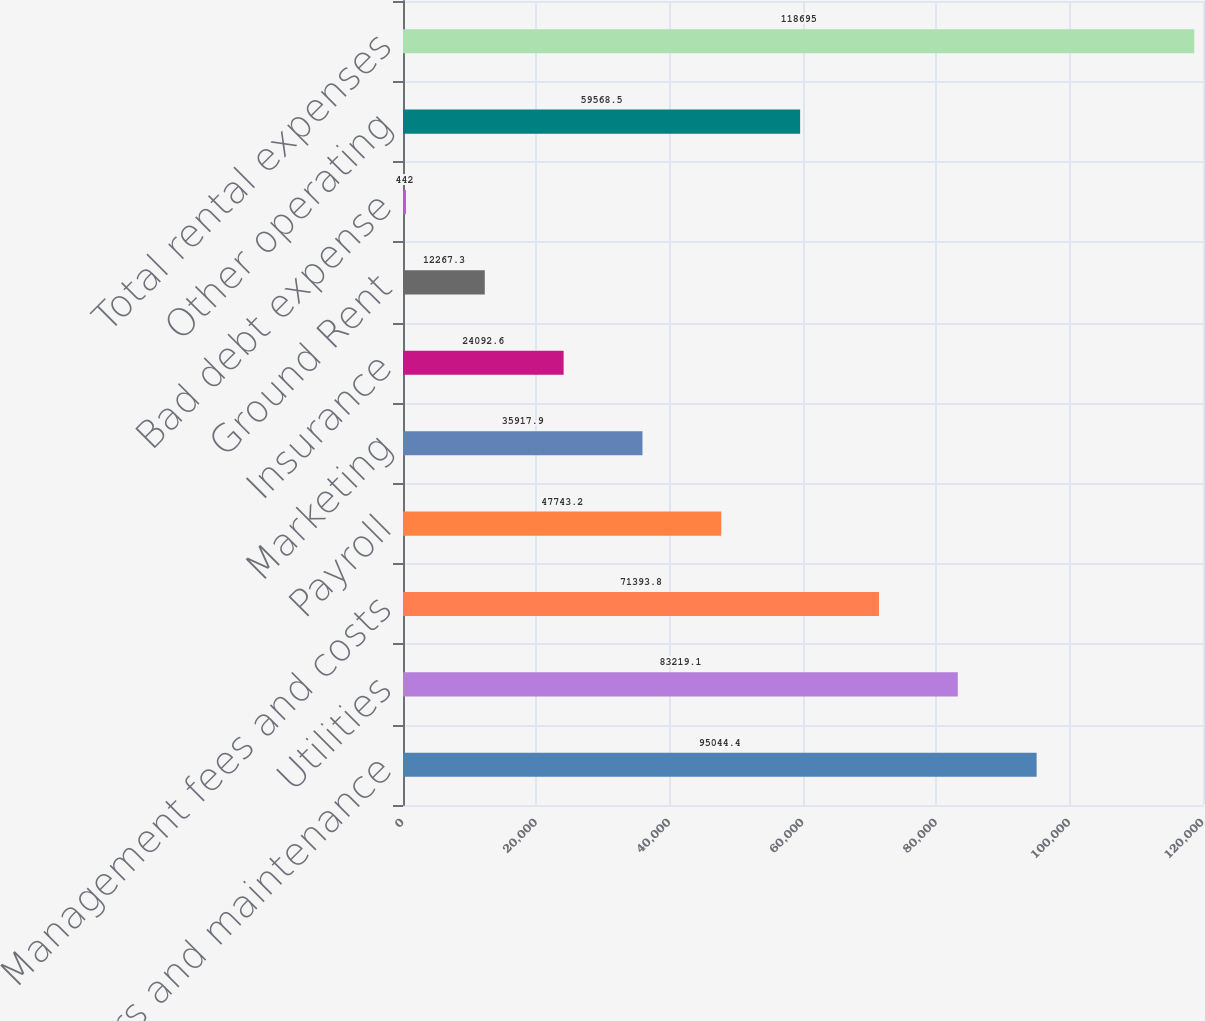Convert chart. <chart><loc_0><loc_0><loc_500><loc_500><bar_chart><fcel>Repairs and maintenance<fcel>Utilities<fcel>Management fees and costs<fcel>Payroll<fcel>Marketing<fcel>Insurance<fcel>Ground Rent<fcel>Bad debt expense<fcel>Other operating<fcel>Total rental expenses<nl><fcel>95044.4<fcel>83219.1<fcel>71393.8<fcel>47743.2<fcel>35917.9<fcel>24092.6<fcel>12267.3<fcel>442<fcel>59568.5<fcel>118695<nl></chart> 